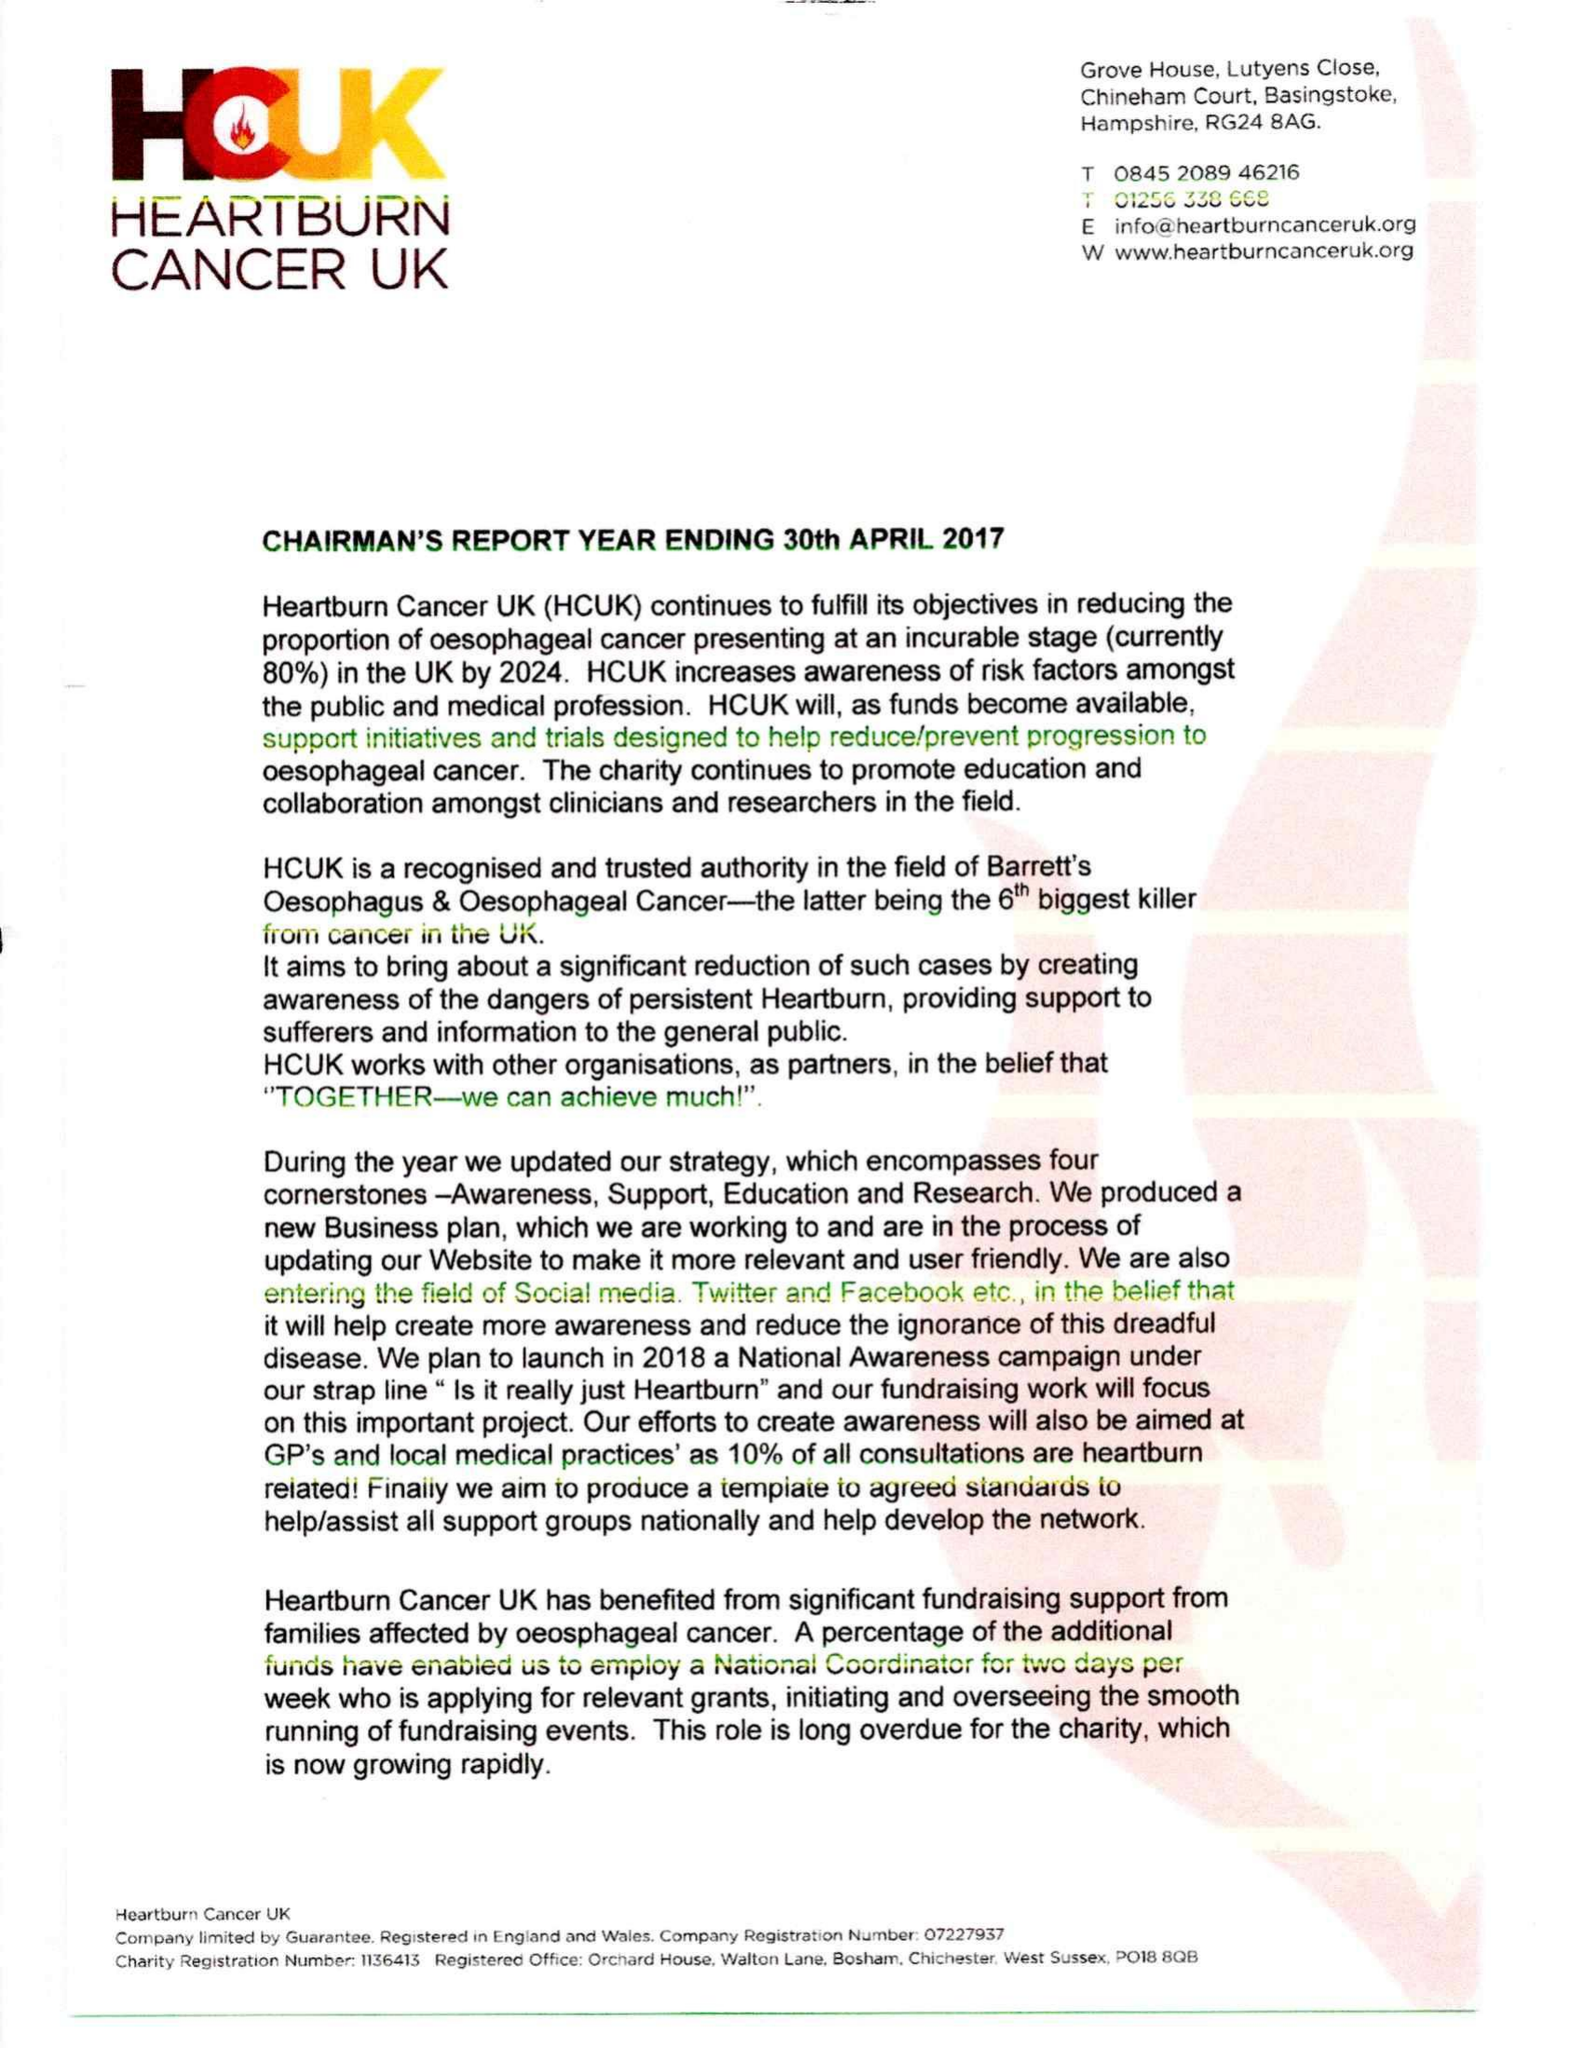What is the value for the address__street_line?
Answer the question using a single word or phrase. WALTON LANE 